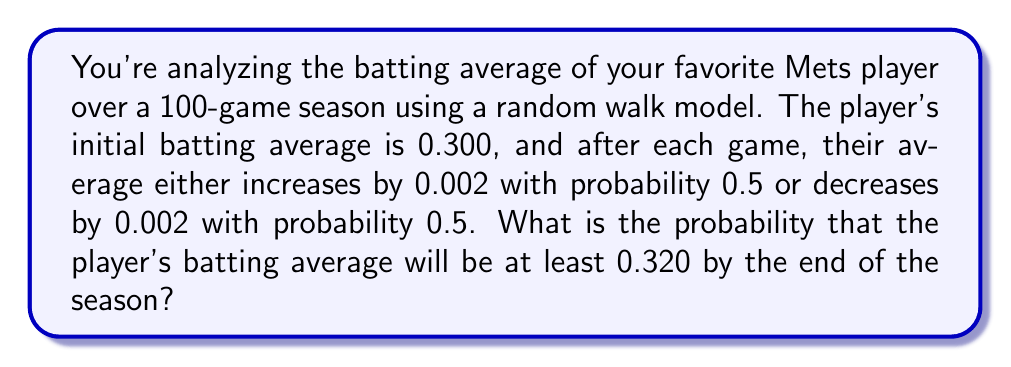Teach me how to tackle this problem. Let's approach this step-by-step:

1) First, we need to recognize this as a random walk problem. The batting average is performing a random walk with steps of ±0.002.

2) To reach a batting average of 0.320 from 0.300, the player needs a net increase of 0.020.

3) Since each step is 0.002, the number of net positive steps needed is:
   $\frac{0.020}{0.002} = 10$ steps

4) In a 100-game season, we're looking for the probability of having at least 10 more increases than decreases.

5) Let X be the number of increases. Then we need P(X ≥ 55), as 55 increases and 45 decreases would give us a net of 10 increases.

6) This follows a binomial distribution with n = 100 and p = 0.5.

7) We can use the normal approximation to the binomial distribution since np and n(1-p) are both > 5.

8) The mean of this distribution is μ = np = 100 * 0.5 = 50
   The standard deviation is σ = √(np(1-p)) = √(100 * 0.5 * 0.5) = 5

9) We need to find P(X ≥ 55), which is equivalent to P(Z ≥ (55-50)/5) = P(Z ≥ 1)

10) Using a standard normal table, we find that P(Z ≥ 1) ≈ 0.1587

Therefore, the probability is approximately 0.1587 or 15.87%.
Answer: 0.1587 